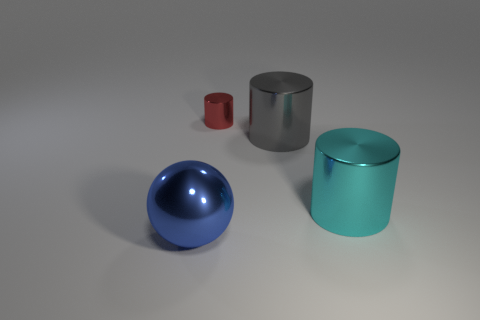Subtract all gray cylinders. Subtract all green blocks. How many cylinders are left? 2 Add 2 tiny yellow things. How many objects exist? 6 Subtract all spheres. How many objects are left? 3 Subtract all small red cylinders. Subtract all large green metallic spheres. How many objects are left? 3 Add 3 red objects. How many red objects are left? 4 Add 1 big cyan cylinders. How many big cyan cylinders exist? 2 Subtract 0 blue cylinders. How many objects are left? 4 